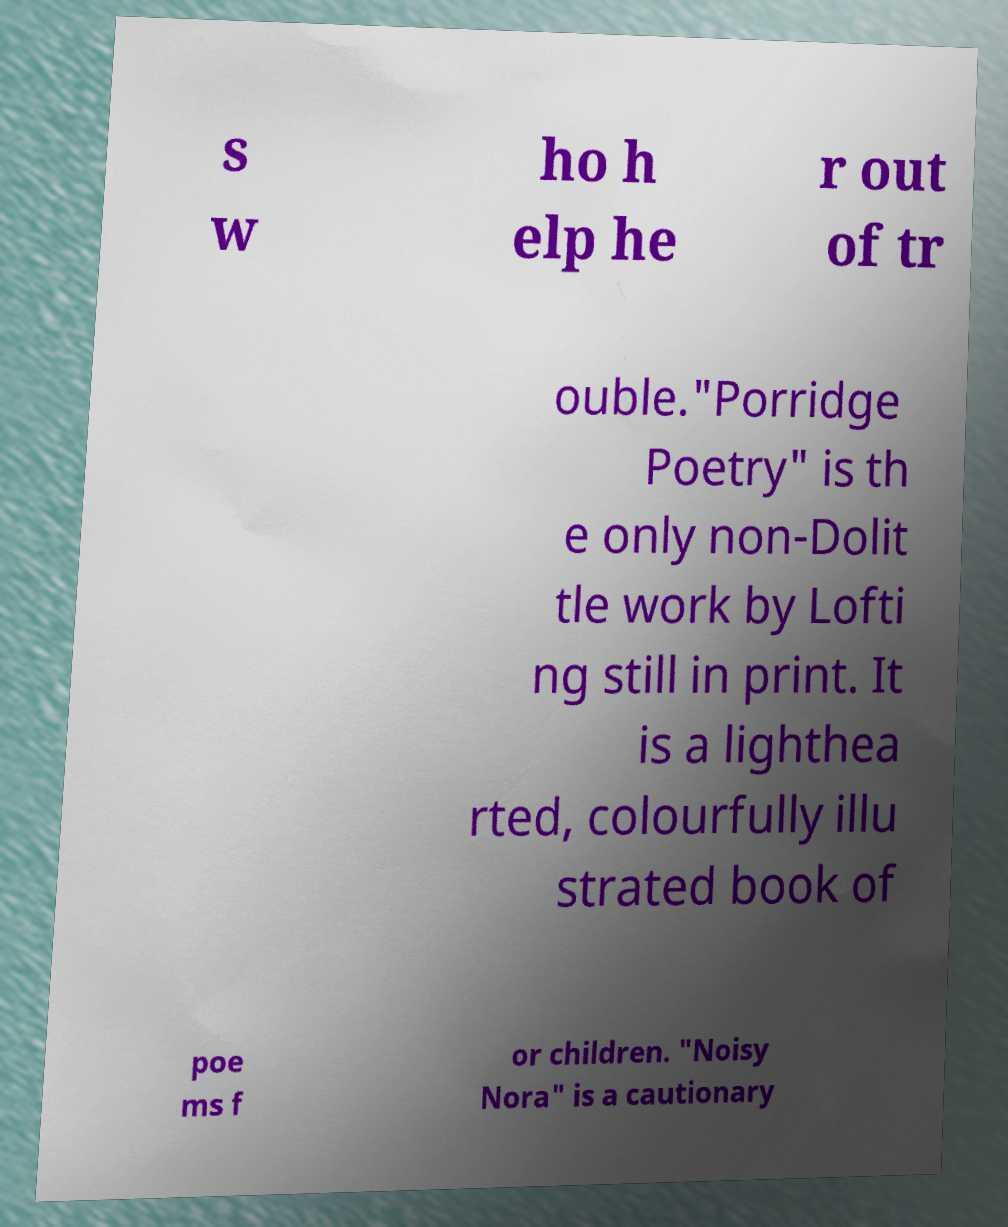Could you assist in decoding the text presented in this image and type it out clearly? s w ho h elp he r out of tr ouble."Porridge Poetry" is th e only non-Dolit tle work by Lofti ng still in print. It is a lighthea rted, colourfully illu strated book of poe ms f or children. "Noisy Nora" is a cautionary 